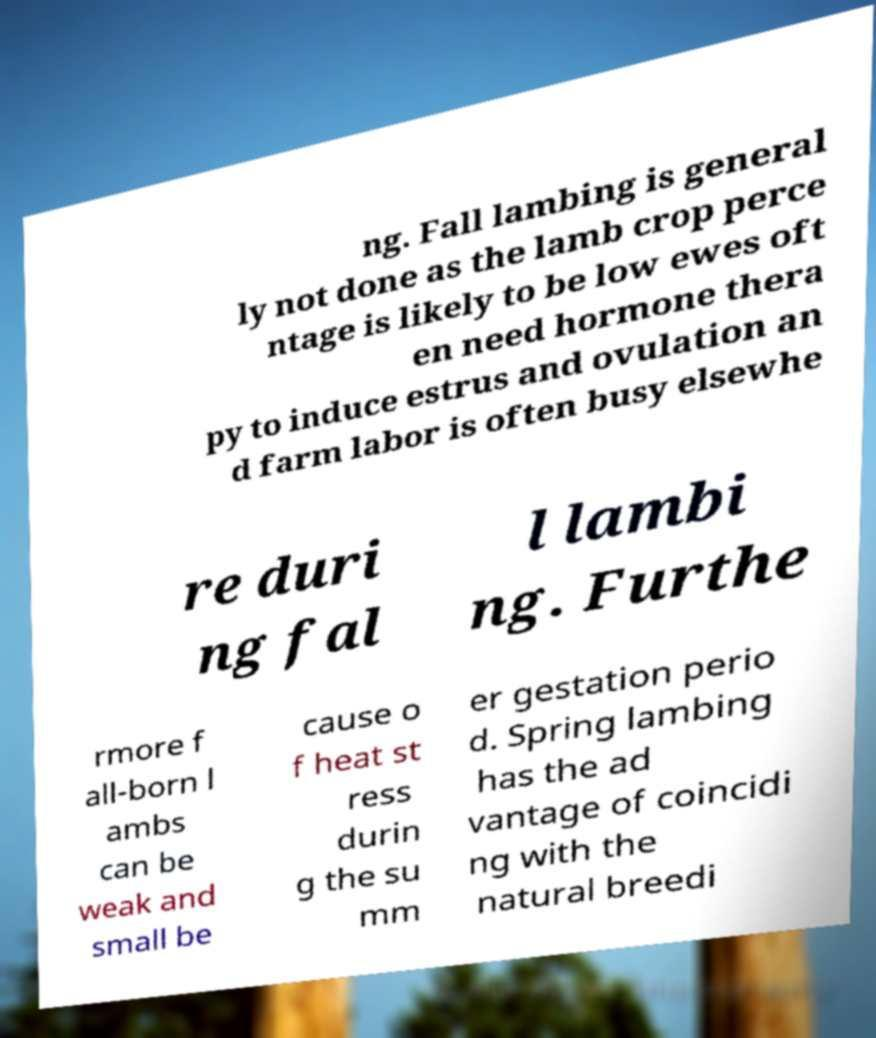Could you extract and type out the text from this image? ng. Fall lambing is general ly not done as the lamb crop perce ntage is likely to be low ewes oft en need hormone thera py to induce estrus and ovulation an d farm labor is often busy elsewhe re duri ng fal l lambi ng. Furthe rmore f all-born l ambs can be weak and small be cause o f heat st ress durin g the su mm er gestation perio d. Spring lambing has the ad vantage of coincidi ng with the natural breedi 